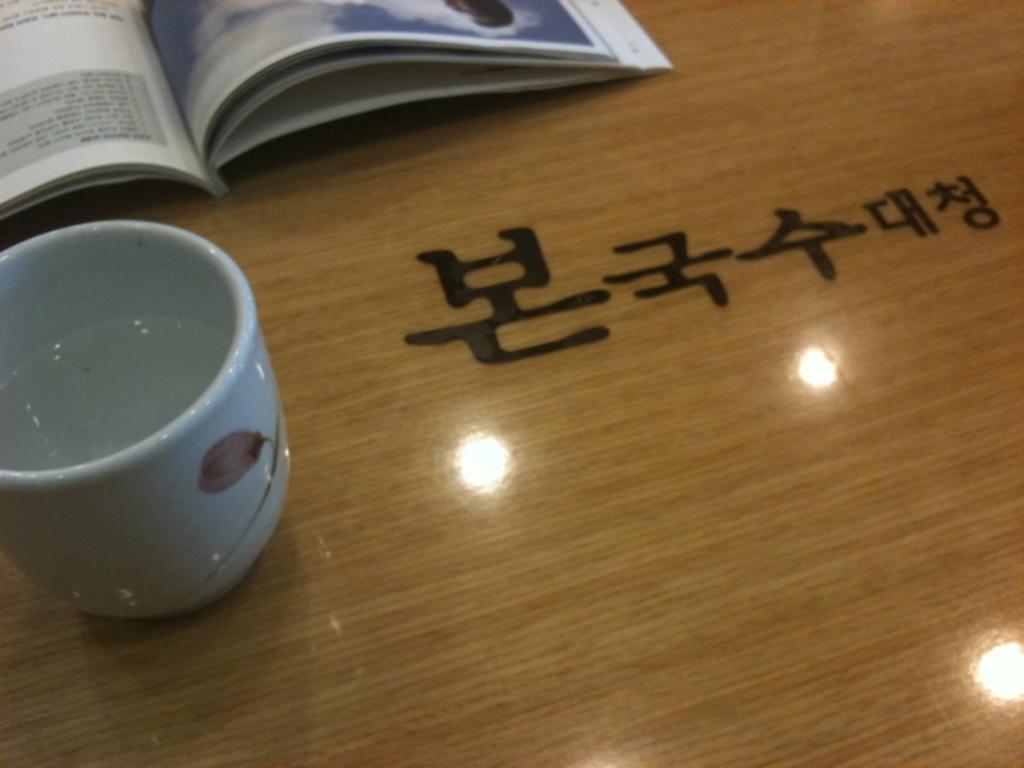How would you summarize this image in a sentence or two? In this picture I can observe a cup on the left side. There is a book placed on the table which is in brown color. I can observe some text on the table. 